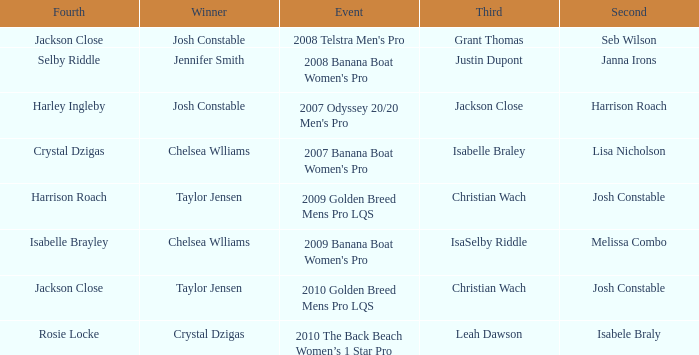Who was the Winner when Selby Riddle came in Fourth? Jennifer Smith. 